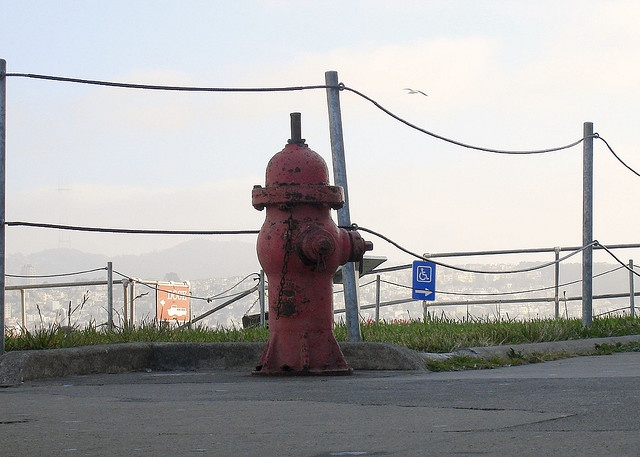Describe the objects in this image and their specific colors. I can see fire hydrant in lavender, black, maroon, and brown tones and bird in lavender, lightgray, darkgray, and gray tones in this image. 